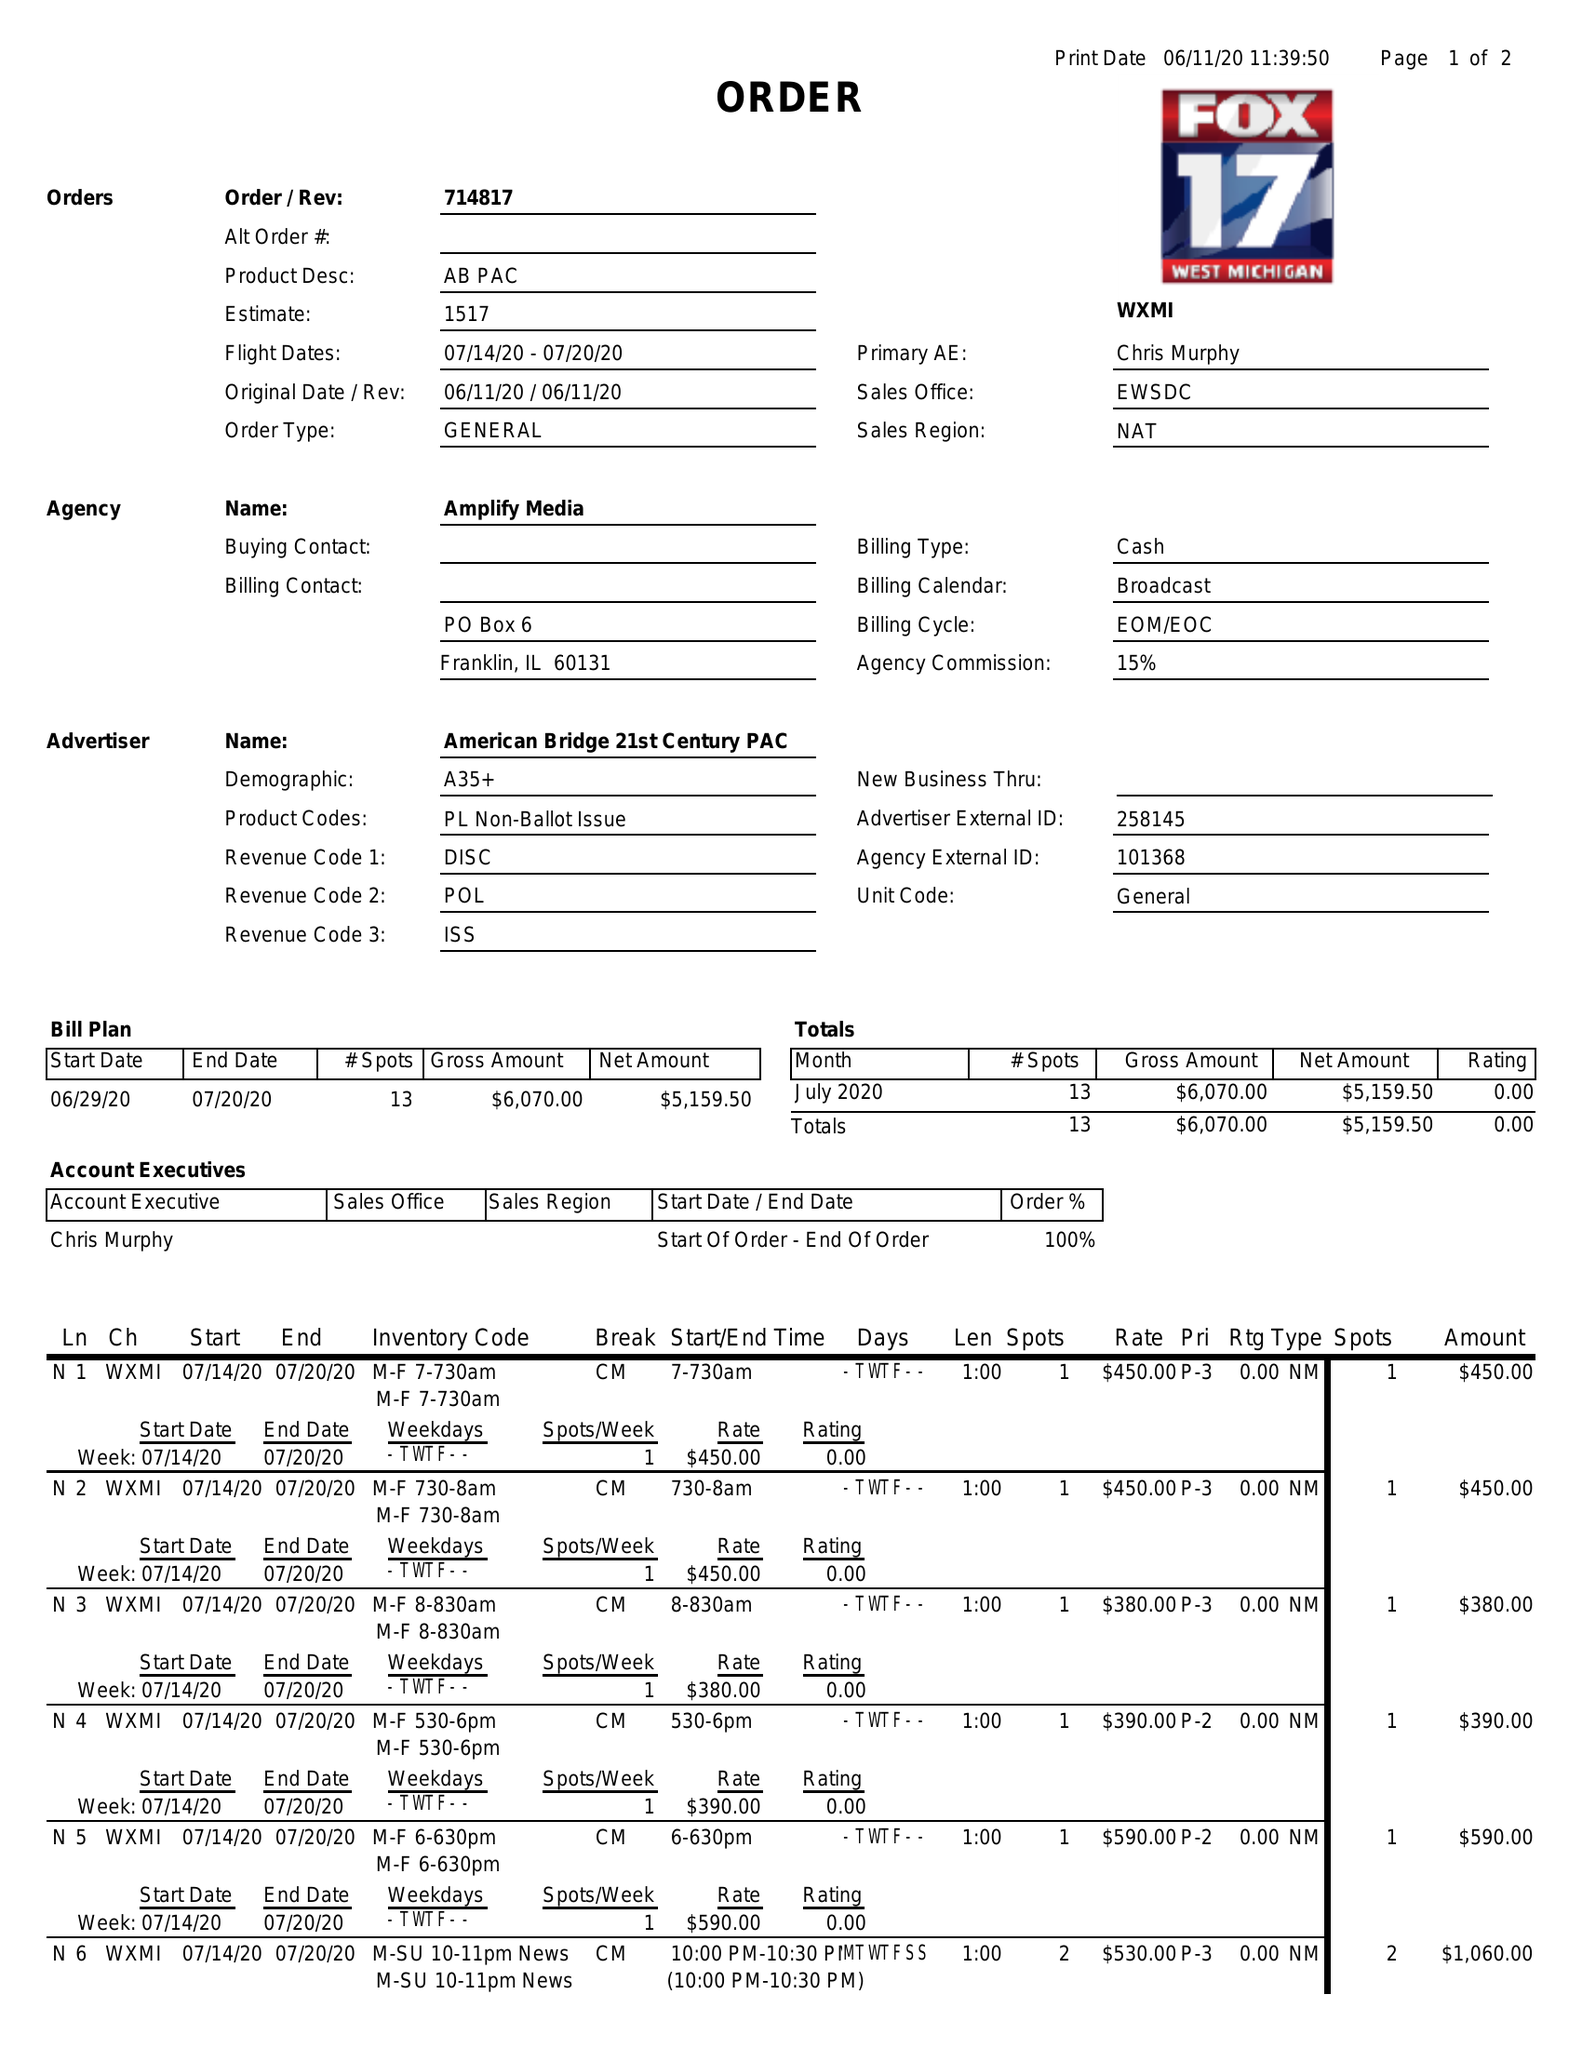What is the value for the gross_amount?
Answer the question using a single word or phrase. 6070.00 